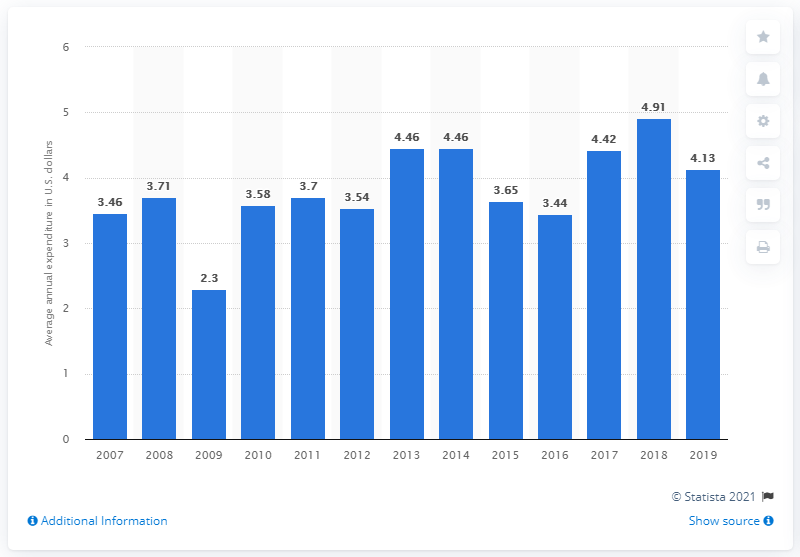Point out several critical features in this image. In 2019, the average expenditure on window air conditioners per consumer unit in the United States was $4.13. 